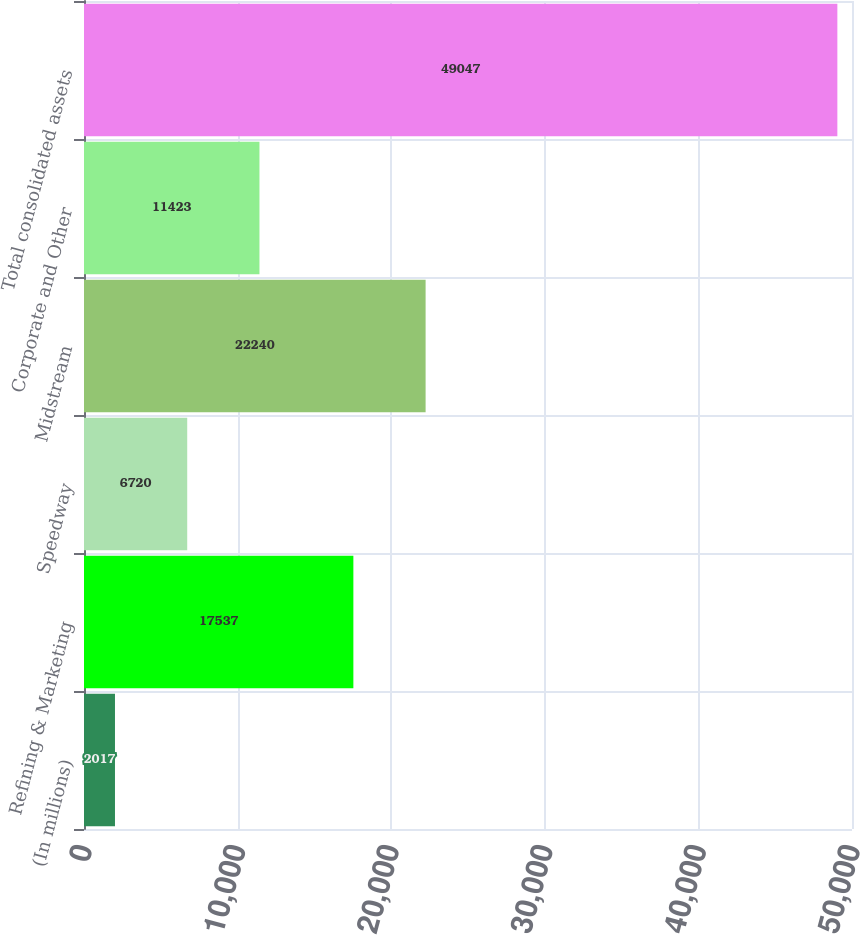<chart> <loc_0><loc_0><loc_500><loc_500><bar_chart><fcel>(In millions)<fcel>Refining & Marketing<fcel>Speedway<fcel>Midstream<fcel>Corporate and Other<fcel>Total consolidated assets<nl><fcel>2017<fcel>17537<fcel>6720<fcel>22240<fcel>11423<fcel>49047<nl></chart> 